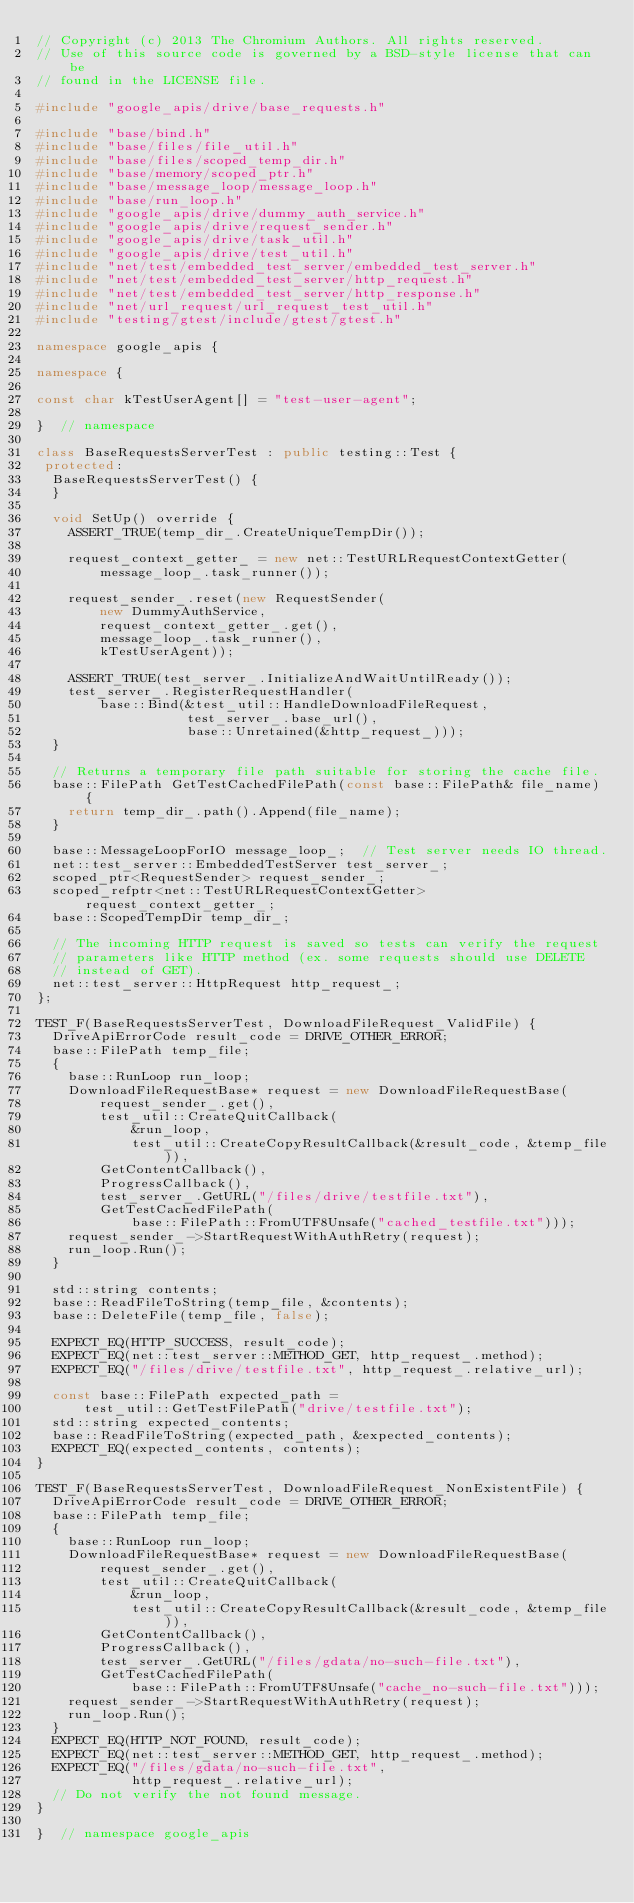<code> <loc_0><loc_0><loc_500><loc_500><_C++_>// Copyright (c) 2013 The Chromium Authors. All rights reserved.
// Use of this source code is governed by a BSD-style license that can be
// found in the LICENSE file.

#include "google_apis/drive/base_requests.h"

#include "base/bind.h"
#include "base/files/file_util.h"
#include "base/files/scoped_temp_dir.h"
#include "base/memory/scoped_ptr.h"
#include "base/message_loop/message_loop.h"
#include "base/run_loop.h"
#include "google_apis/drive/dummy_auth_service.h"
#include "google_apis/drive/request_sender.h"
#include "google_apis/drive/task_util.h"
#include "google_apis/drive/test_util.h"
#include "net/test/embedded_test_server/embedded_test_server.h"
#include "net/test/embedded_test_server/http_request.h"
#include "net/test/embedded_test_server/http_response.h"
#include "net/url_request/url_request_test_util.h"
#include "testing/gtest/include/gtest/gtest.h"

namespace google_apis {

namespace {

const char kTestUserAgent[] = "test-user-agent";

}  // namespace

class BaseRequestsServerTest : public testing::Test {
 protected:
  BaseRequestsServerTest() {
  }

  void SetUp() override {
    ASSERT_TRUE(temp_dir_.CreateUniqueTempDir());

    request_context_getter_ = new net::TestURLRequestContextGetter(
        message_loop_.task_runner());

    request_sender_.reset(new RequestSender(
        new DummyAuthService,
        request_context_getter_.get(),
        message_loop_.task_runner(),
        kTestUserAgent));

    ASSERT_TRUE(test_server_.InitializeAndWaitUntilReady());
    test_server_.RegisterRequestHandler(
        base::Bind(&test_util::HandleDownloadFileRequest,
                   test_server_.base_url(),
                   base::Unretained(&http_request_)));
  }

  // Returns a temporary file path suitable for storing the cache file.
  base::FilePath GetTestCachedFilePath(const base::FilePath& file_name) {
    return temp_dir_.path().Append(file_name);
  }

  base::MessageLoopForIO message_loop_;  // Test server needs IO thread.
  net::test_server::EmbeddedTestServer test_server_;
  scoped_ptr<RequestSender> request_sender_;
  scoped_refptr<net::TestURLRequestContextGetter> request_context_getter_;
  base::ScopedTempDir temp_dir_;

  // The incoming HTTP request is saved so tests can verify the request
  // parameters like HTTP method (ex. some requests should use DELETE
  // instead of GET).
  net::test_server::HttpRequest http_request_;
};

TEST_F(BaseRequestsServerTest, DownloadFileRequest_ValidFile) {
  DriveApiErrorCode result_code = DRIVE_OTHER_ERROR;
  base::FilePath temp_file;
  {
    base::RunLoop run_loop;
    DownloadFileRequestBase* request = new DownloadFileRequestBase(
        request_sender_.get(),
        test_util::CreateQuitCallback(
            &run_loop,
            test_util::CreateCopyResultCallback(&result_code, &temp_file)),
        GetContentCallback(),
        ProgressCallback(),
        test_server_.GetURL("/files/drive/testfile.txt"),
        GetTestCachedFilePath(
            base::FilePath::FromUTF8Unsafe("cached_testfile.txt")));
    request_sender_->StartRequestWithAuthRetry(request);
    run_loop.Run();
  }

  std::string contents;
  base::ReadFileToString(temp_file, &contents);
  base::DeleteFile(temp_file, false);

  EXPECT_EQ(HTTP_SUCCESS, result_code);
  EXPECT_EQ(net::test_server::METHOD_GET, http_request_.method);
  EXPECT_EQ("/files/drive/testfile.txt", http_request_.relative_url);

  const base::FilePath expected_path =
      test_util::GetTestFilePath("drive/testfile.txt");
  std::string expected_contents;
  base::ReadFileToString(expected_path, &expected_contents);
  EXPECT_EQ(expected_contents, contents);
}

TEST_F(BaseRequestsServerTest, DownloadFileRequest_NonExistentFile) {
  DriveApiErrorCode result_code = DRIVE_OTHER_ERROR;
  base::FilePath temp_file;
  {
    base::RunLoop run_loop;
    DownloadFileRequestBase* request = new DownloadFileRequestBase(
        request_sender_.get(),
        test_util::CreateQuitCallback(
            &run_loop,
            test_util::CreateCopyResultCallback(&result_code, &temp_file)),
        GetContentCallback(),
        ProgressCallback(),
        test_server_.GetURL("/files/gdata/no-such-file.txt"),
        GetTestCachedFilePath(
            base::FilePath::FromUTF8Unsafe("cache_no-such-file.txt")));
    request_sender_->StartRequestWithAuthRetry(request);
    run_loop.Run();
  }
  EXPECT_EQ(HTTP_NOT_FOUND, result_code);
  EXPECT_EQ(net::test_server::METHOD_GET, http_request_.method);
  EXPECT_EQ("/files/gdata/no-such-file.txt",
            http_request_.relative_url);
  // Do not verify the not found message.
}

}  // namespace google_apis
</code> 